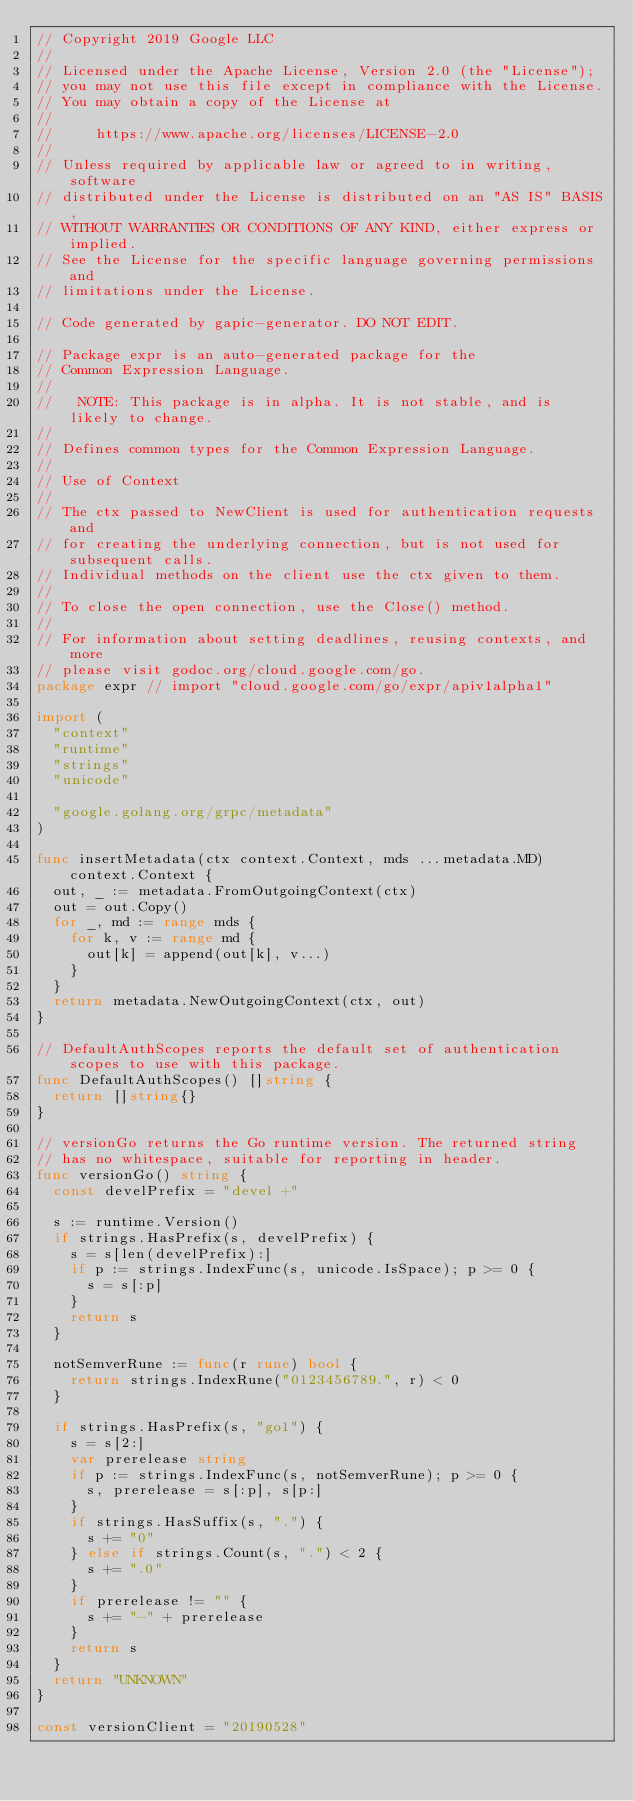<code> <loc_0><loc_0><loc_500><loc_500><_Go_>// Copyright 2019 Google LLC
//
// Licensed under the Apache License, Version 2.0 (the "License");
// you may not use this file except in compliance with the License.
// You may obtain a copy of the License at
//
//     https://www.apache.org/licenses/LICENSE-2.0
//
// Unless required by applicable law or agreed to in writing, software
// distributed under the License is distributed on an "AS IS" BASIS,
// WITHOUT WARRANTIES OR CONDITIONS OF ANY KIND, either express or implied.
// See the License for the specific language governing permissions and
// limitations under the License.

// Code generated by gapic-generator. DO NOT EDIT.

// Package expr is an auto-generated package for the
// Common Expression Language.
//
//   NOTE: This package is in alpha. It is not stable, and is likely to change.
//
// Defines common types for the Common Expression Language.
//
// Use of Context
//
// The ctx passed to NewClient is used for authentication requests and
// for creating the underlying connection, but is not used for subsequent calls.
// Individual methods on the client use the ctx given to them.
//
// To close the open connection, use the Close() method.
//
// For information about setting deadlines, reusing contexts, and more
// please visit godoc.org/cloud.google.com/go.
package expr // import "cloud.google.com/go/expr/apiv1alpha1"

import (
	"context"
	"runtime"
	"strings"
	"unicode"

	"google.golang.org/grpc/metadata"
)

func insertMetadata(ctx context.Context, mds ...metadata.MD) context.Context {
	out, _ := metadata.FromOutgoingContext(ctx)
	out = out.Copy()
	for _, md := range mds {
		for k, v := range md {
			out[k] = append(out[k], v...)
		}
	}
	return metadata.NewOutgoingContext(ctx, out)
}

// DefaultAuthScopes reports the default set of authentication scopes to use with this package.
func DefaultAuthScopes() []string {
	return []string{}
}

// versionGo returns the Go runtime version. The returned string
// has no whitespace, suitable for reporting in header.
func versionGo() string {
	const develPrefix = "devel +"

	s := runtime.Version()
	if strings.HasPrefix(s, develPrefix) {
		s = s[len(develPrefix):]
		if p := strings.IndexFunc(s, unicode.IsSpace); p >= 0 {
			s = s[:p]
		}
		return s
	}

	notSemverRune := func(r rune) bool {
		return strings.IndexRune("0123456789.", r) < 0
	}

	if strings.HasPrefix(s, "go1") {
		s = s[2:]
		var prerelease string
		if p := strings.IndexFunc(s, notSemverRune); p >= 0 {
			s, prerelease = s[:p], s[p:]
		}
		if strings.HasSuffix(s, ".") {
			s += "0"
		} else if strings.Count(s, ".") < 2 {
			s += ".0"
		}
		if prerelease != "" {
			s += "-" + prerelease
		}
		return s
	}
	return "UNKNOWN"
}

const versionClient = "20190528"
</code> 